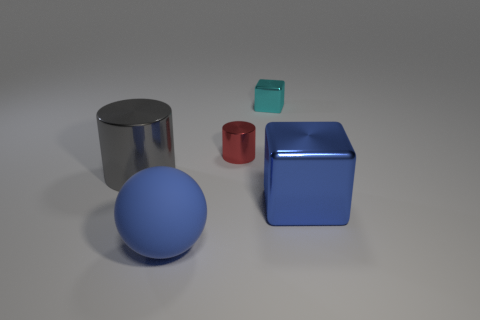Please provide the possible materials for the objects based on their appearances. Based on their appearances, the objects might be made of different materials: the shiny cylinder and blue cube look metallic, perhaps steel or aluminum, due to their reflective nature. The matte sphere could be made of a plastic or rubber with a non-reflective surface. The smaller cube seems like it could be made of tinted glass or translucent plastic. 